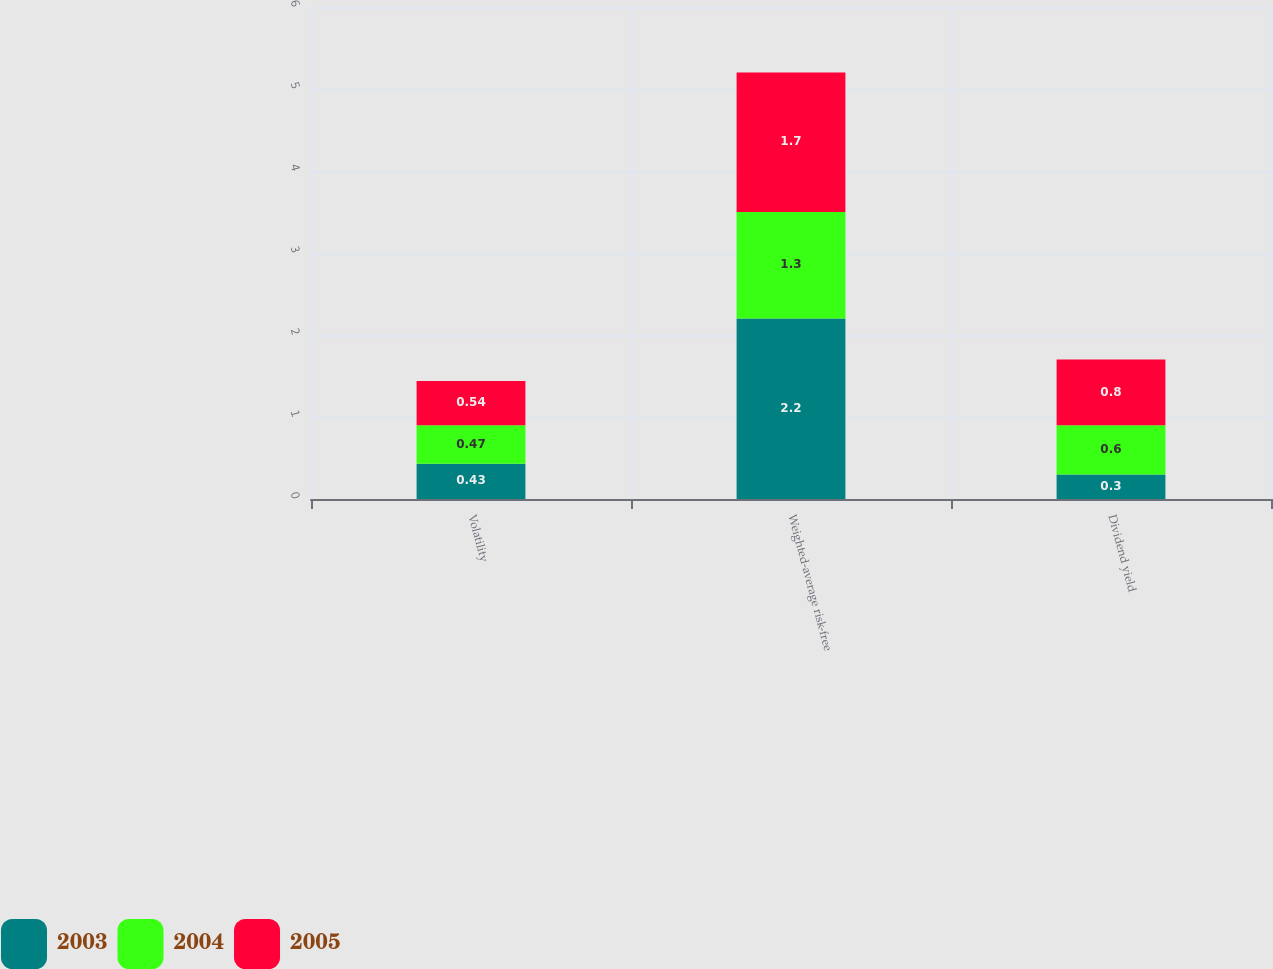<chart> <loc_0><loc_0><loc_500><loc_500><stacked_bar_chart><ecel><fcel>Volatility<fcel>Weighted-average risk-free<fcel>Dividend yield<nl><fcel>2003<fcel>0.43<fcel>2.2<fcel>0.3<nl><fcel>2004<fcel>0.47<fcel>1.3<fcel>0.6<nl><fcel>2005<fcel>0.54<fcel>1.7<fcel>0.8<nl></chart> 